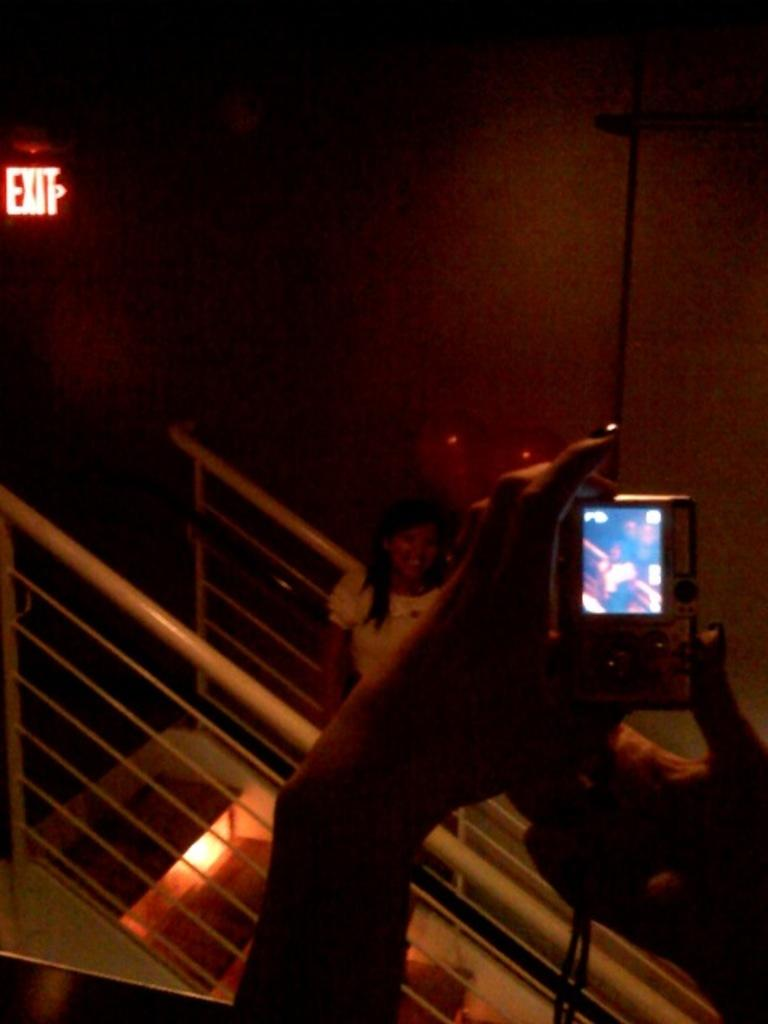<image>
Share a concise interpretation of the image provided. a lady posing for a photo near an exit 